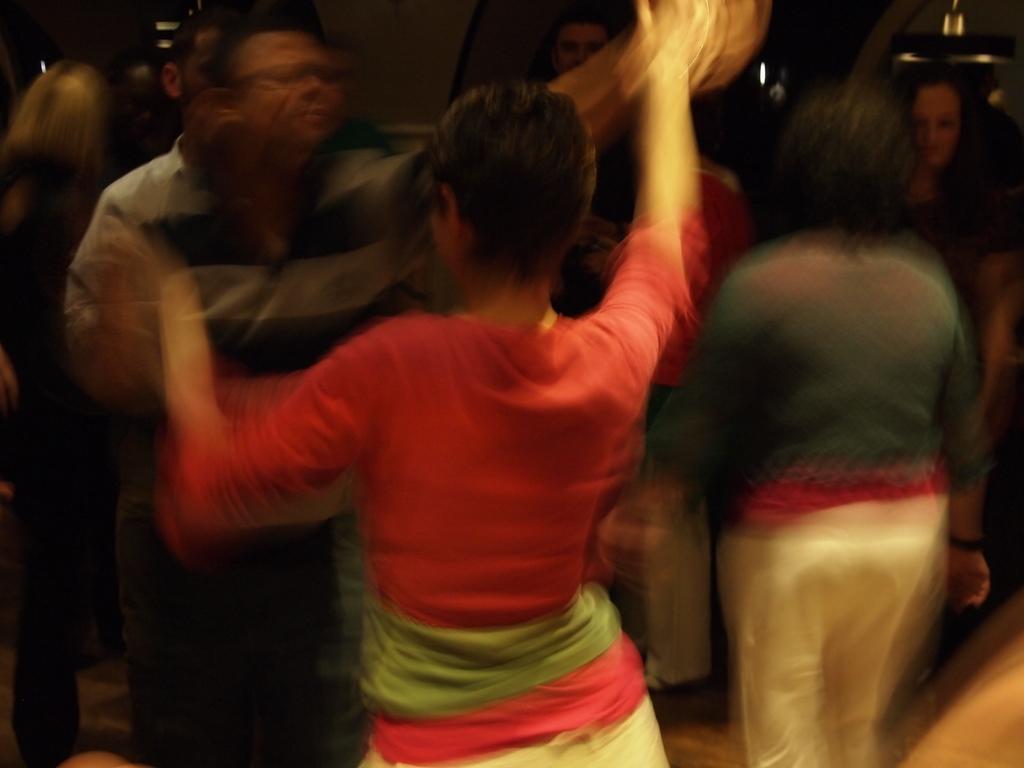Could you give a brief overview of what you see in this image? It is a blur image, there are a group of people in the picture. 